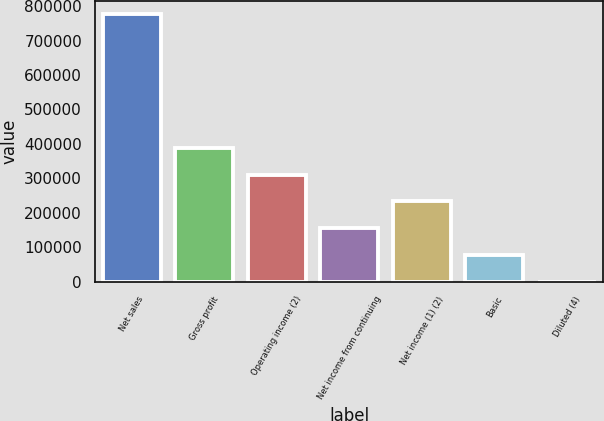<chart> <loc_0><loc_0><loc_500><loc_500><bar_chart><fcel>Net sales<fcel>Gross profit<fcel>Operating income (2)<fcel>Net income from continuing<fcel>Net income (1) (2)<fcel>Basic<fcel>Diluted (4)<nl><fcel>776166<fcel>388083<fcel>310467<fcel>155234<fcel>232850<fcel>77617.3<fcel>0.74<nl></chart> 